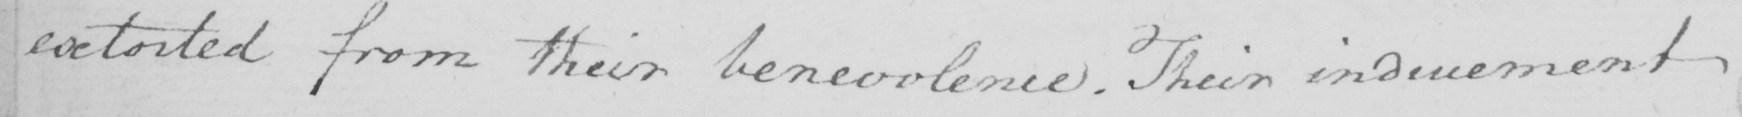Please provide the text content of this handwritten line. extorted from their benevolence . Their inducement 